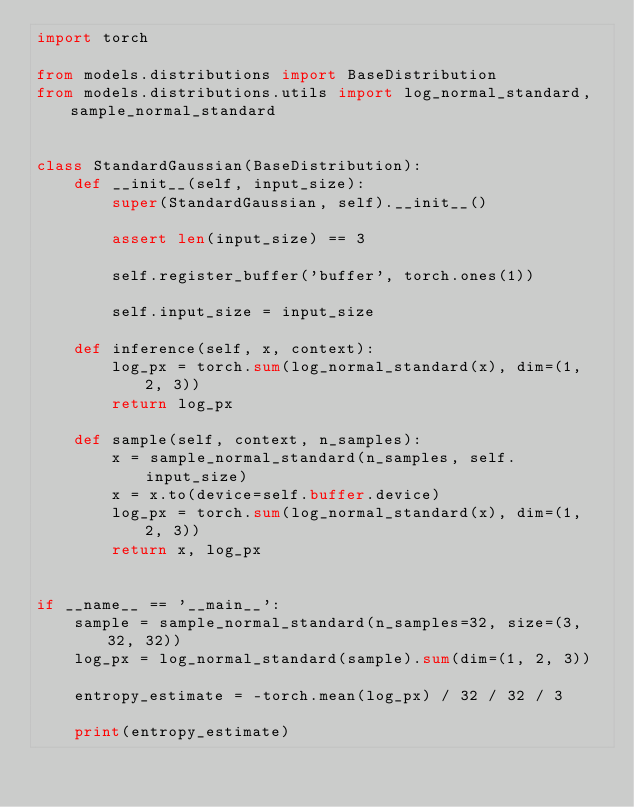<code> <loc_0><loc_0><loc_500><loc_500><_Python_>import torch

from models.distributions import BaseDistribution
from models.distributions.utils import log_normal_standard, sample_normal_standard


class StandardGaussian(BaseDistribution):
    def __init__(self, input_size):
        super(StandardGaussian, self).__init__()

        assert len(input_size) == 3

        self.register_buffer('buffer', torch.ones(1))

        self.input_size = input_size

    def inference(self, x, context):
        log_px = torch.sum(log_normal_standard(x), dim=(1, 2, 3))
        return log_px

    def sample(self, context, n_samples):
        x = sample_normal_standard(n_samples, self.input_size)
        x = x.to(device=self.buffer.device)
        log_px = torch.sum(log_normal_standard(x), dim=(1, 2, 3))
        return x, log_px


if __name__ == '__main__':
    sample = sample_normal_standard(n_samples=32, size=(3, 32, 32))
    log_px = log_normal_standard(sample).sum(dim=(1, 2, 3))

    entropy_estimate = -torch.mean(log_px) / 32 / 32 / 3

    print(entropy_estimate)</code> 